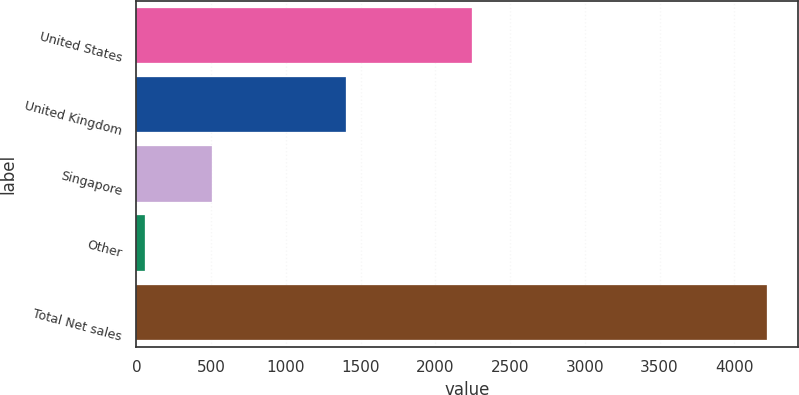Convert chart. <chart><loc_0><loc_0><loc_500><loc_500><bar_chart><fcel>United States<fcel>United Kingdom<fcel>Singapore<fcel>Other<fcel>Total Net sales<nl><fcel>2247<fcel>1403<fcel>508<fcel>60<fcel>4218<nl></chart> 